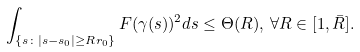<formula> <loc_0><loc_0><loc_500><loc_500>\int _ { \{ s \colon | s - s _ { 0 } | \geq R r _ { 0 } \} } F ( \gamma ( s ) ) ^ { 2 } d s \leq \Theta ( R ) , \, \forall R \in [ 1 , \bar { R } ] .</formula> 